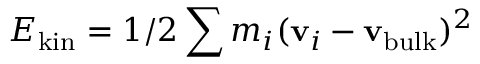Convert formula to latex. <formula><loc_0><loc_0><loc_500><loc_500>E _ { k i n } = 1 / 2 \sum m _ { i } ( { v } _ { i } - { v _ { b u l k } } ) ^ { 2 }</formula> 